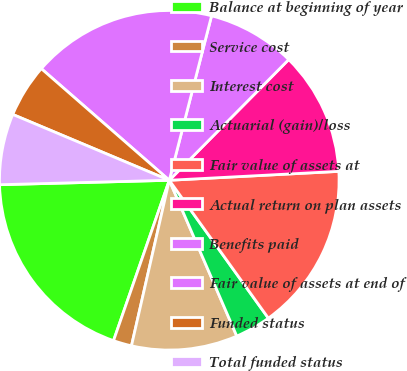Convert chart. <chart><loc_0><loc_0><loc_500><loc_500><pie_chart><fcel>Balance at beginning of year<fcel>Service cost<fcel>Interest cost<fcel>Actuarial (gain)/loss<fcel>Fair value of assets at<fcel>Actual return on plan assets<fcel>Benefits paid<fcel>Fair value of assets at end of<fcel>Funded status<fcel>Total funded status<nl><fcel>19.26%<fcel>1.75%<fcel>10.08%<fcel>3.41%<fcel>15.92%<fcel>11.75%<fcel>8.41%<fcel>17.59%<fcel>5.08%<fcel>6.75%<nl></chart> 